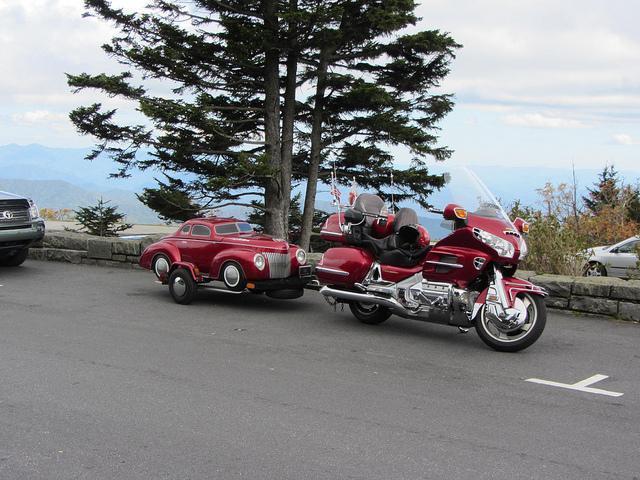How many cars are in the picture?
Give a very brief answer. 3. How many cars are there?
Give a very brief answer. 3. How many tusks does the elephant on the left have?
Give a very brief answer. 0. 